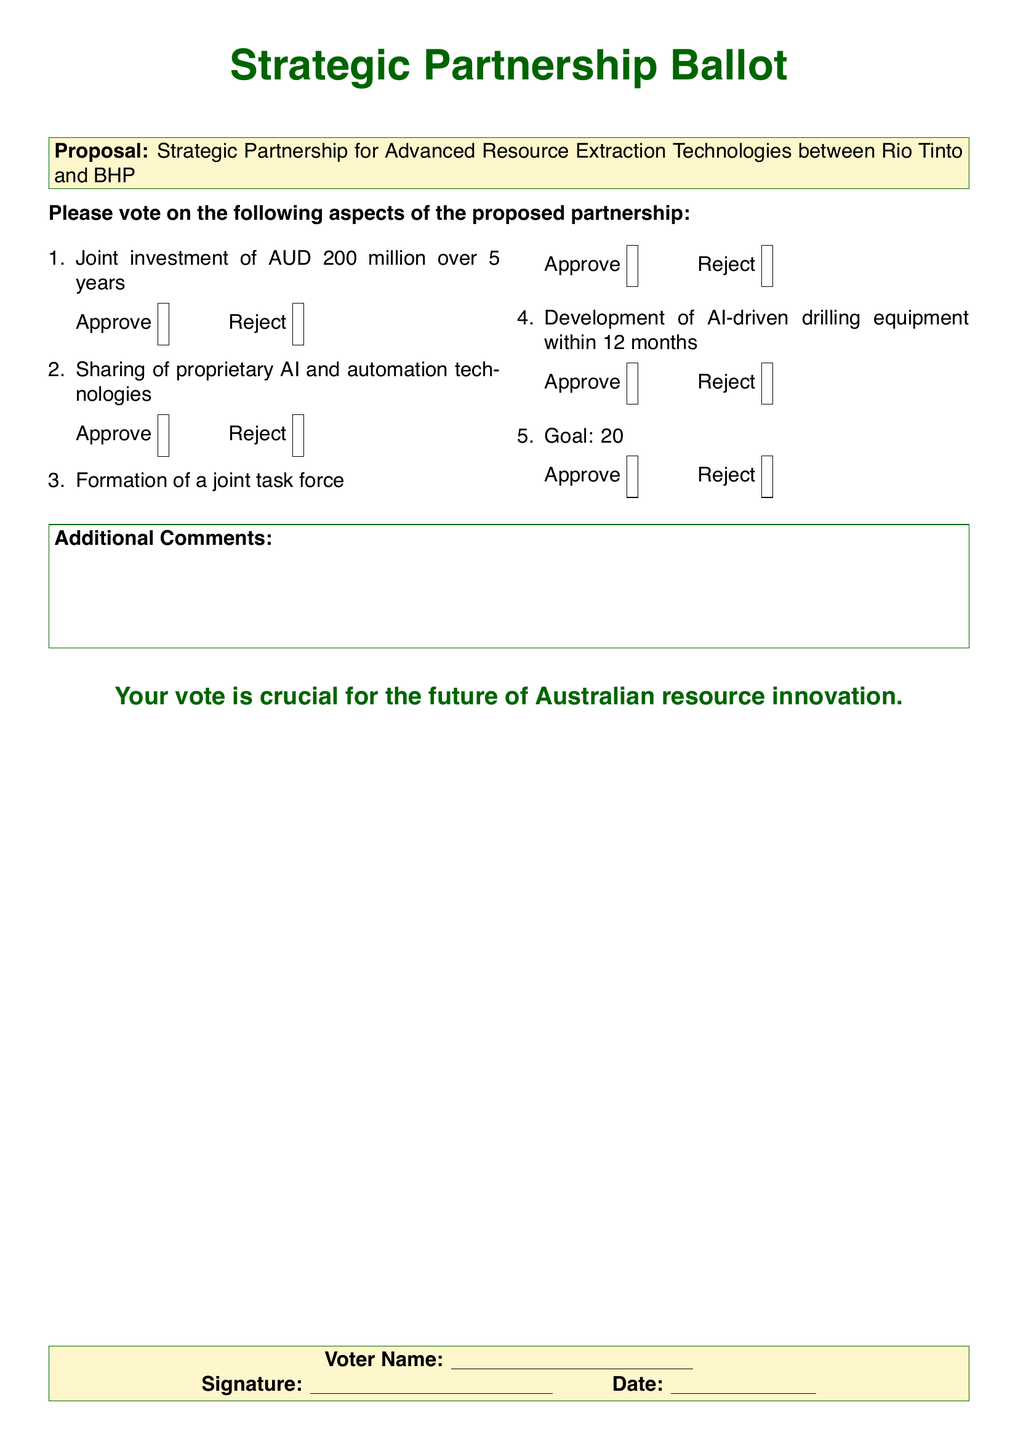What is the proposed investment amount? The document states that the proposed investment amount is AUD 200 million over 5 years.
Answer: AUD 200 million What is the duration of the investment? The document specifies that the investment duration is 5 years.
Answer: 5 years Who are the collaborating parties? The document mentions the collaboration is between Rio Tinto and BHP.
Answer: Rio Tinto and BHP What is the goal for resource extraction efficiency increase? The document indicates that the goal is a 20% increase in resource extraction efficiency.
Answer: 20% How many aspects are to be voted on? The document lists five aspects for voting in the partnership proposal.
Answer: Five What technology is to be shared in the partnership? The document states that proprietary AI and automation technologies will be shared.
Answer: AI and automation technologies What is the time frame for developing AI-driven drilling equipment? The document states that the timeframe for development is within 12 months.
Answer: 12 months What is the additional section for comments titled? The section for comments is titled "Additional Comments."
Answer: Additional Comments Is a joint task force proposed in the partnership? The document mentions the formation of a joint task force.
Answer: Yes 